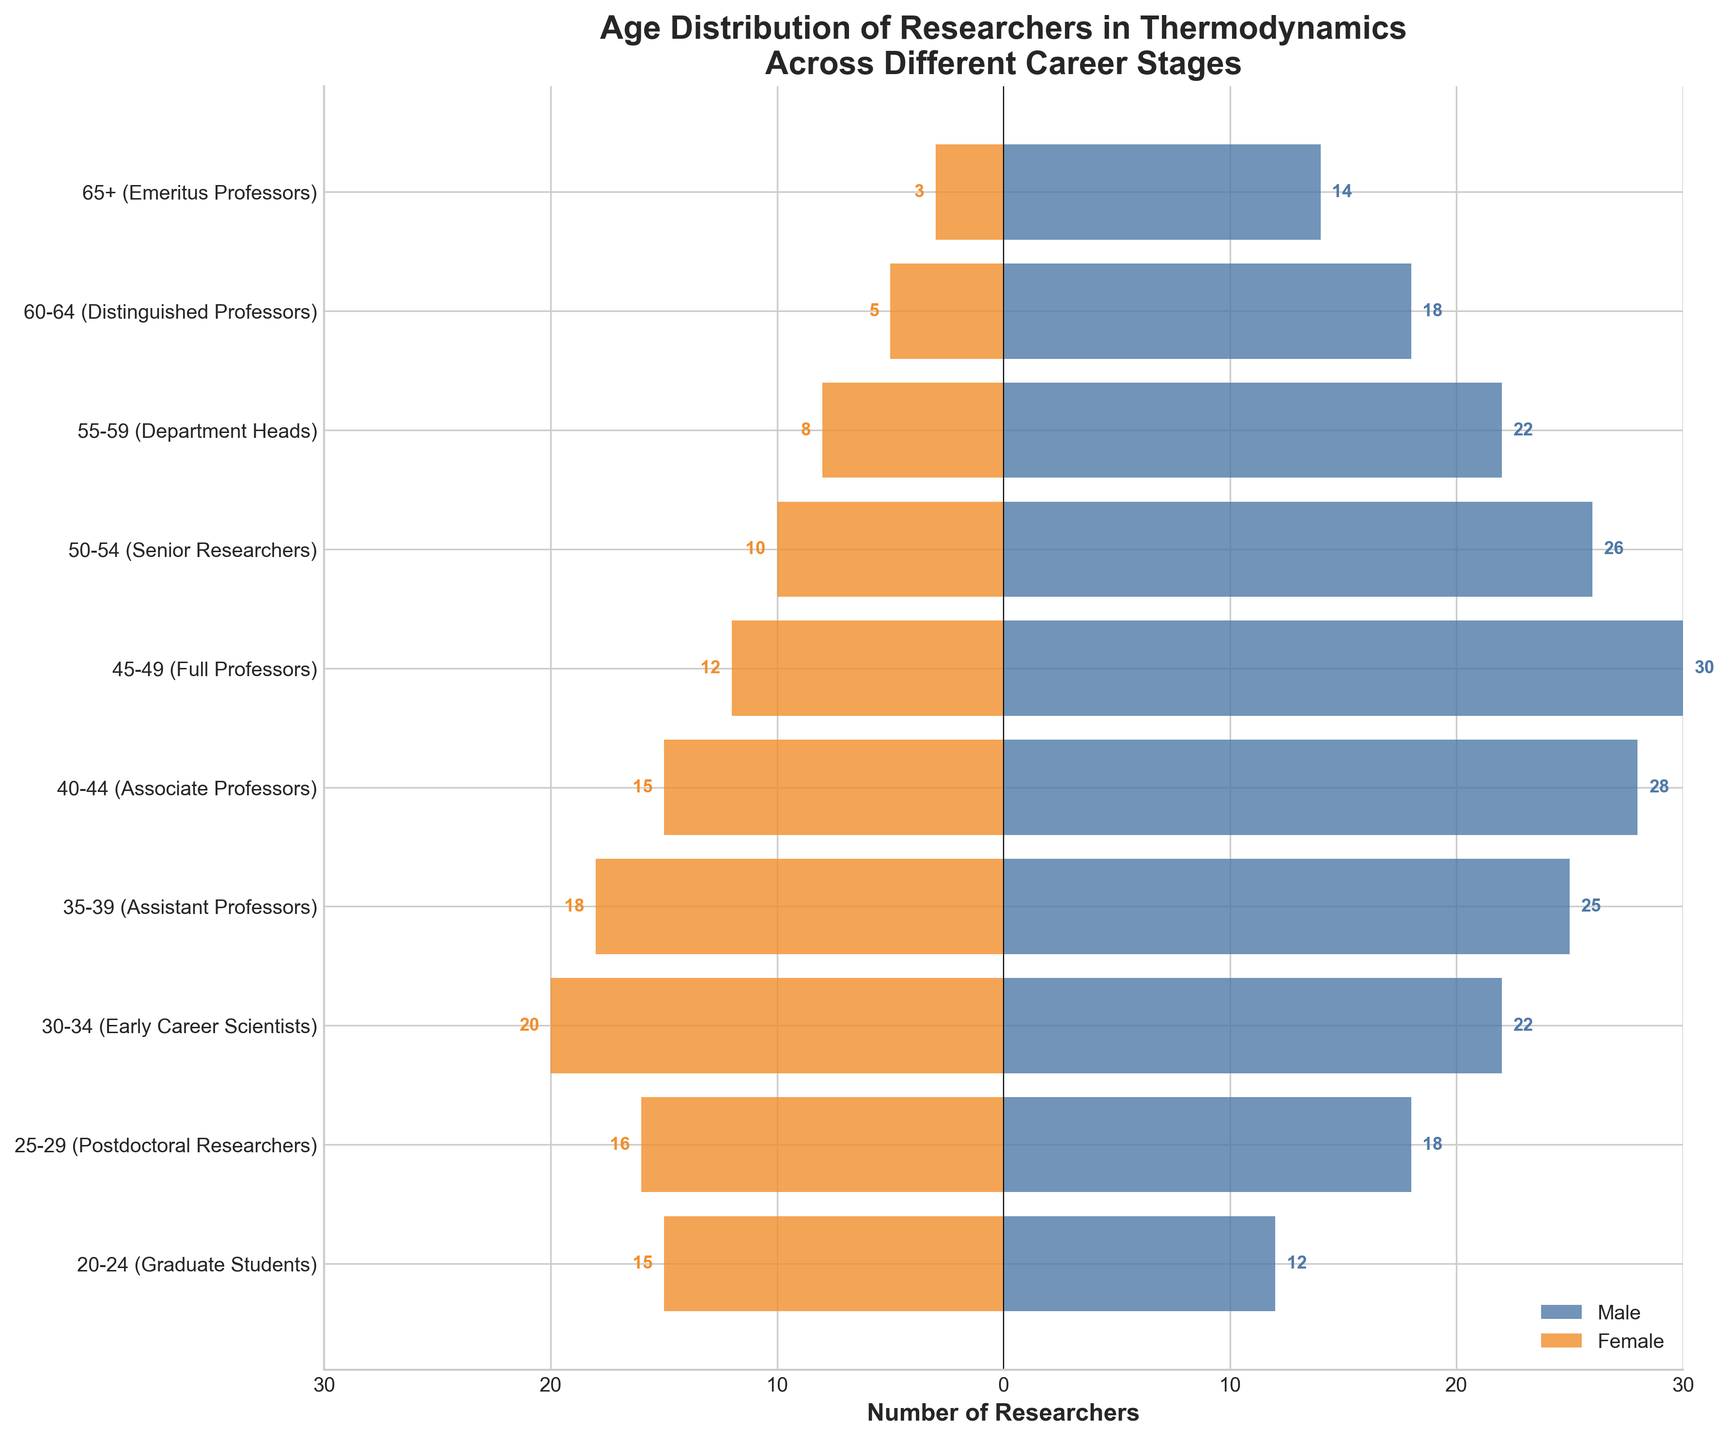What is the title of the figure? The title of the figure is written at the top.
Answer: Age Distribution of Researchers in Thermodynamics Across Different Career Stages How many male Postdoctoral Researchers are there? The male Postdoctoral Researchers are represented by the horizontal bar at '25-29 (Postdoctoral Researchers)'. The value at the end of the bar is 18.
Answer: 18 Which career stage has the highest number of female researchers? Look for the longest horizontal bar on the negative side (representing female researchers). The longest bar belongs to the '20-24 (Graduate Students)' category with 15 female researchers.
Answer: 20-24 (Graduate Students) What is the total number of Assistant Professors? Add the number of male and female Assistant Professors. The numbers are 25 (male) and 18 (female). Therefore, 25 + 18 = 43.
Answer: 43 Compare the number of male and female Full Professors. Who is more and by how many? The number of male Full Professors is 30 and female Full Professors is 12. Subtract the number of females from males: 30 - 12 = 18. Therefore, there are 18 more male Full Professors than females.
Answer: Males, by 18 What is the difference in the number of male and female Distinguished Professors? The number of male Distinguished Professors is 18 and female Distinguished Professors is 5. The difference is 18 - 5 = 13.
Answer: 13 Which gender has more researchers in the '50-54 (Senior Researchers)' category, and by how many? The number of male Senior Researchers is 26 and female Senior Researchers is 10. Subtract the number of females from males: 26 - 10 = 16. Therefore, males have more researchers by 16.
Answer: Males, by 16 What is the total number of researchers in the '40-44 (Associate Professors)' category? Add the number of male and female Associate Professors. The numbers are 28 (male) and 15 (female). Therefore, 28 + 15 = 43.
Answer: 43 How many female Emeritus Professors are there? The female Emeritus Professors are represented by the horizontal bar at '65+ (Emeritus Professors)'. The value at the end of the bar is 3.
Answer: 3 Which career stage has more male researchers, 'Early Career Scientists' or 'Senior Researchers', and by how many? The number of male Early Career Scientists is 22 and male Senior Researchers is 26. Subtract the number of Early Career Scientists from Senior Researchers: 26 - 22 = 4. Therefore, Senior Researchers have more male researchers by 4.
Answer: Senior Researchers, by 4 